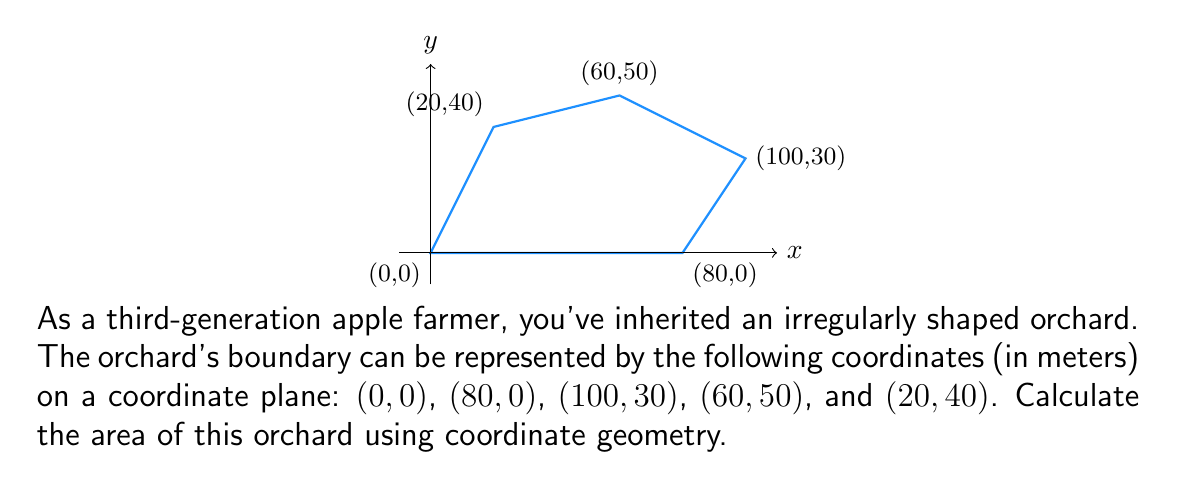Provide a solution to this math problem. To calculate the area of this irregular orchard, we can use the Shoelace formula (also known as the surveyor's formula). This formula calculates the area of a polygon given the coordinates of its vertices.

The formula is:

$$ A = \frac{1}{2}|\sum_{i=1}^{n-1} (x_iy_{i+1} - x_{i+1}y_i) + (x_ny_1 - x_1y_n)| $$

Where $(x_i, y_i)$ are the coordinates of the $i$-th vertex.

Let's apply this formula to our orchard:

1) List the coordinates in order:
   $(0,0)$, $(80,0)$, $(100,30)$, $(60,50)$, $(20,40)$

2) Apply the formula:

   $A = \frac{1}{2}|[(0 \cdot 0) - (80 \cdot 0)] + [(80 \cdot 30) - (100 \cdot 0)] + [(100 \cdot 50) - (60 \cdot 30)] + [(60 \cdot 40) - (20 \cdot 50)] + [(20 \cdot 0) - (0 \cdot 40)]|$

3) Simplify:

   $A = \frac{1}{2}|0 + 2400 + 5000 - 1800 + 2400 - 1000 - 0|$

4) Calculate:

   $A = \frac{1}{2}|7000|$
   $A = \frac{1}{2} \cdot 7000$
   $A = 3500$

Therefore, the area of the orchard is 3500 square meters.
Answer: 3500 m² 